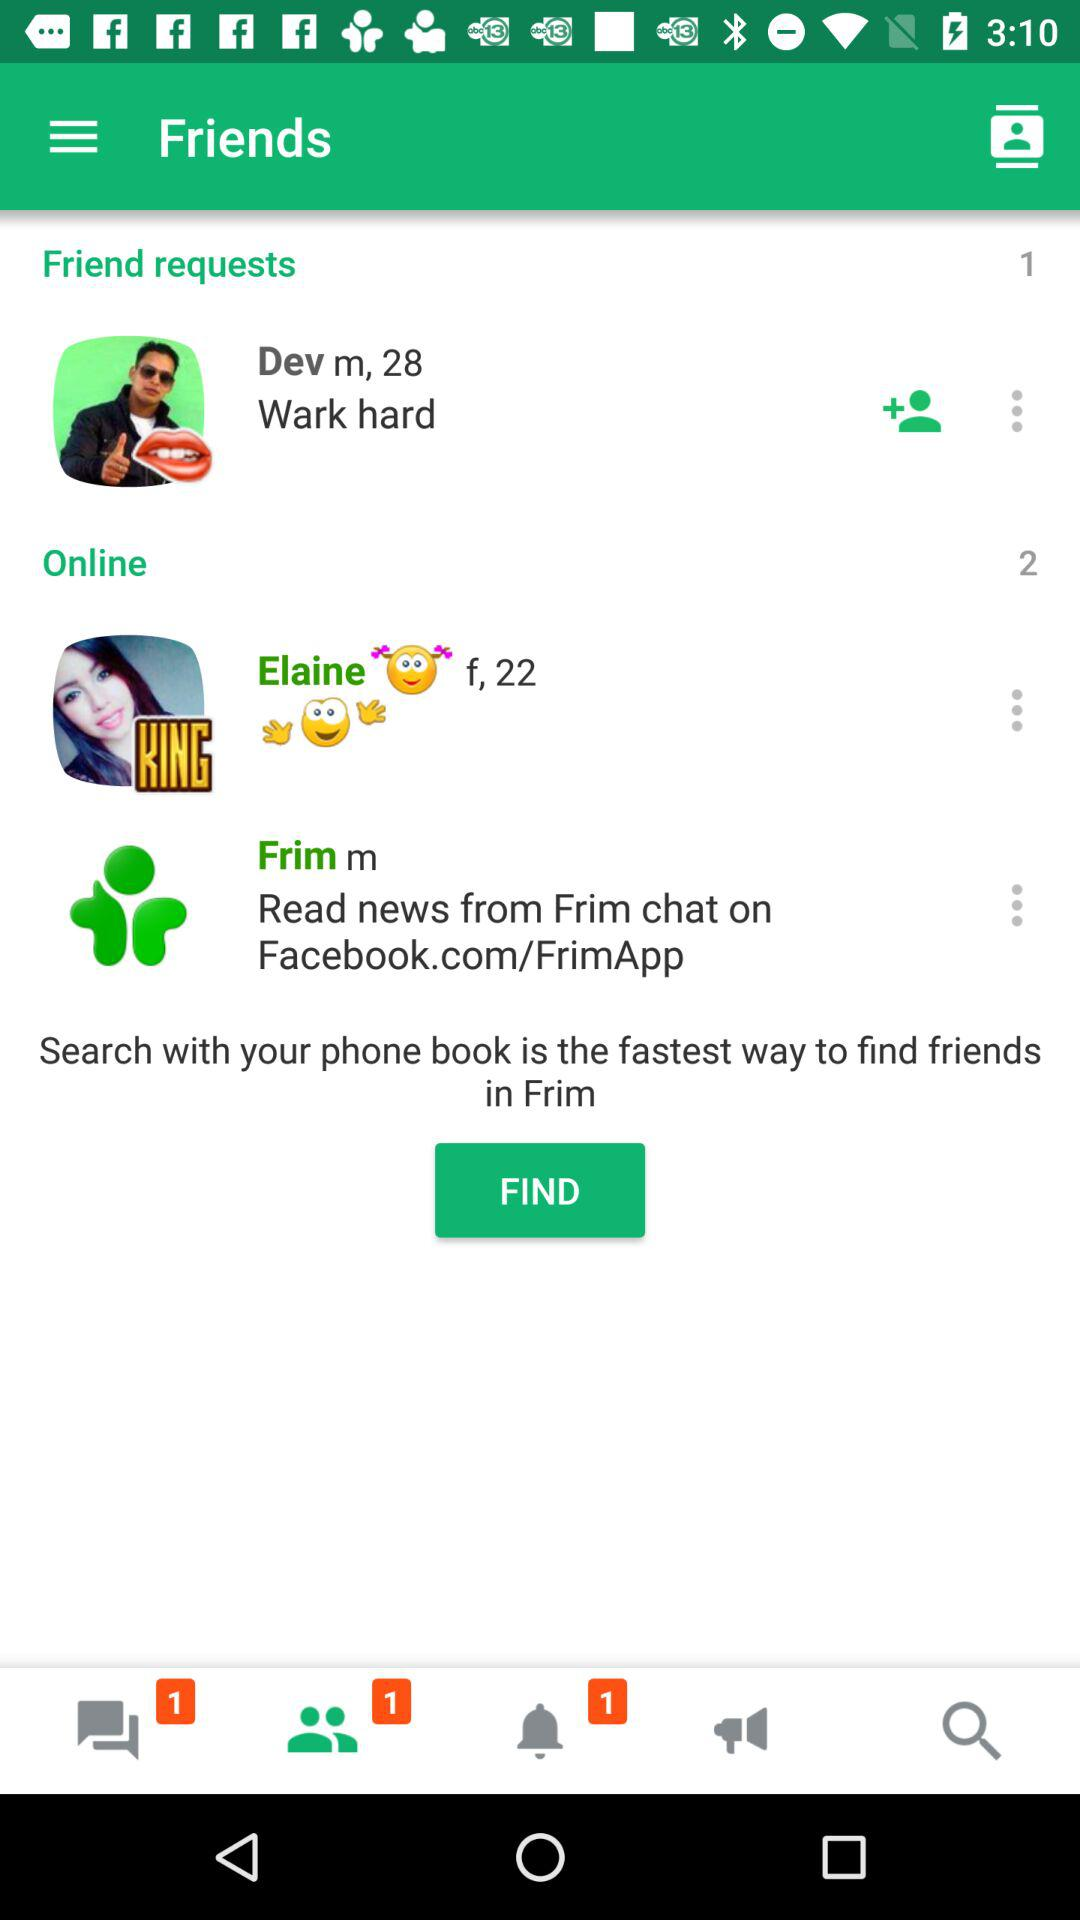How many unread notifications are there? There is 1 unread notification. 